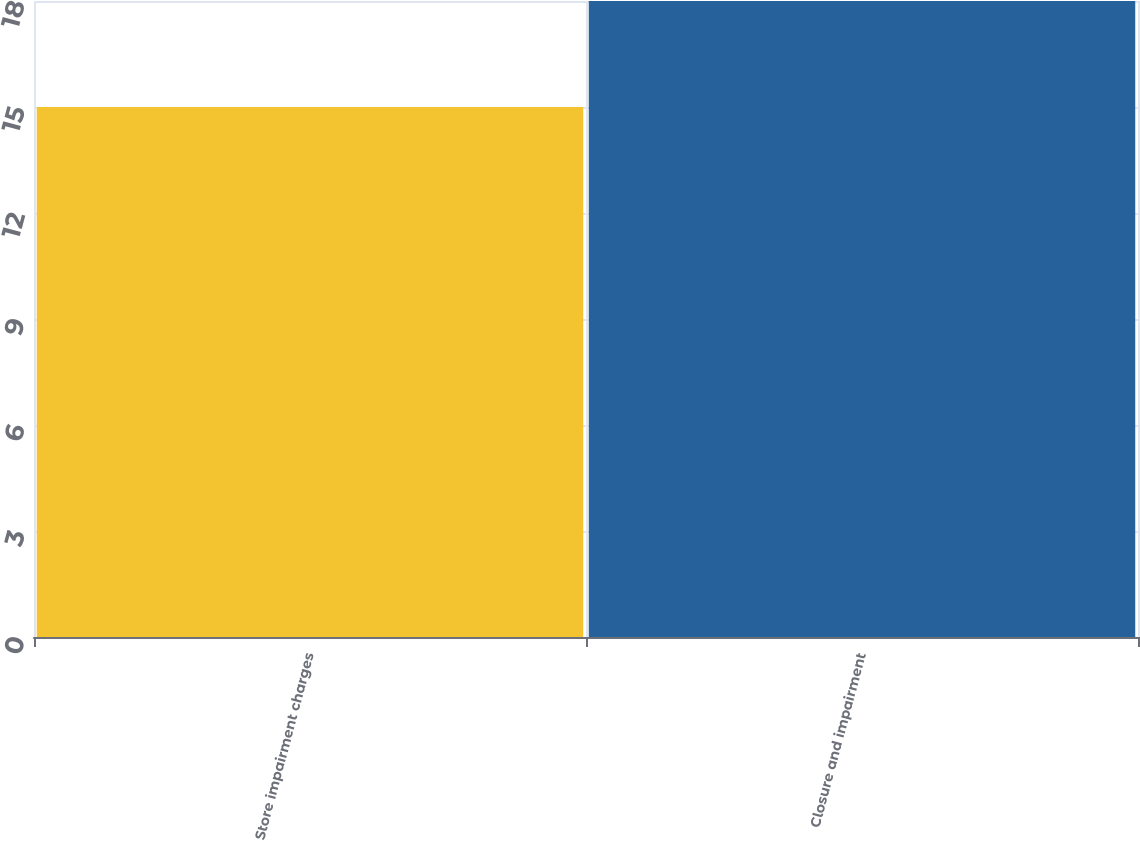<chart> <loc_0><loc_0><loc_500><loc_500><bar_chart><fcel>Store impairment charges<fcel>Closure and impairment<nl><fcel>15<fcel>18<nl></chart> 